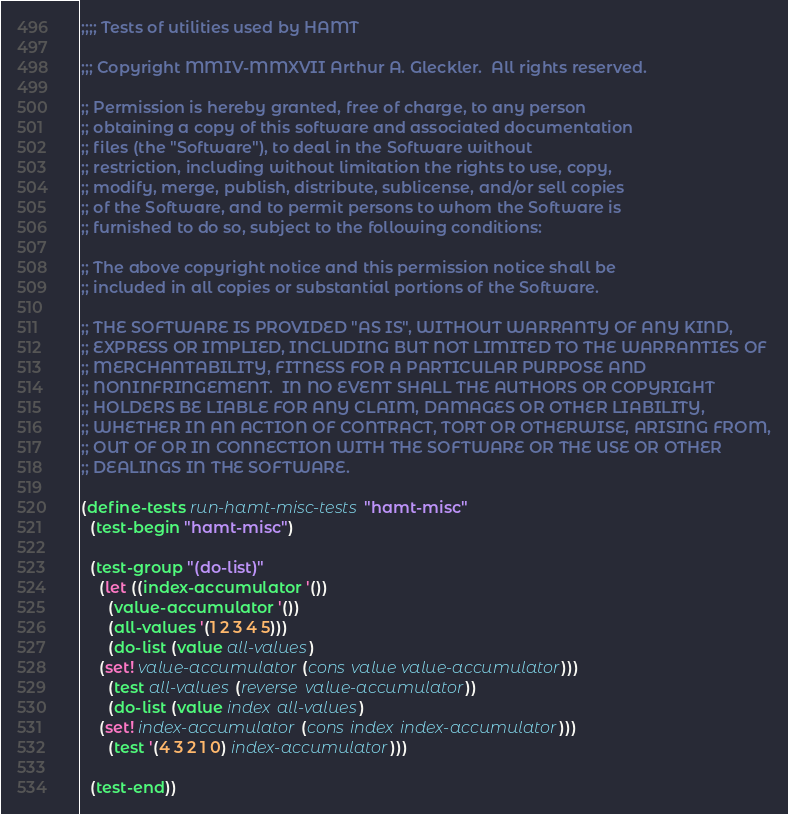Convert code to text. <code><loc_0><loc_0><loc_500><loc_500><_Scheme_>;;;; Tests of utilities used by HAMT

;;; Copyright MMIV-MMXVII Arthur A. Gleckler.  All rights reserved.

;; Permission is hereby granted, free of charge, to any person
;; obtaining a copy of this software and associated documentation
;; files (the "Software"), to deal in the Software without
;; restriction, including without limitation the rights to use, copy,
;; modify, merge, publish, distribute, sublicense, and/or sell copies
;; of the Software, and to permit persons to whom the Software is
;; furnished to do so, subject to the following conditions:

;; The above copyright notice and this permission notice shall be
;; included in all copies or substantial portions of the Software.

;; THE SOFTWARE IS PROVIDED "AS IS", WITHOUT WARRANTY OF ANY KIND,
;; EXPRESS OR IMPLIED, INCLUDING BUT NOT LIMITED TO THE WARRANTIES OF
;; MERCHANTABILITY, FITNESS FOR A PARTICULAR PURPOSE AND
;; NONINFRINGEMENT.  IN NO EVENT SHALL THE AUTHORS OR COPYRIGHT
;; HOLDERS BE LIABLE FOR ANY CLAIM, DAMAGES OR OTHER LIABILITY,
;; WHETHER IN AN ACTION OF CONTRACT, TORT OR OTHERWISE, ARISING FROM,
;; OUT OF OR IN CONNECTION WITH THE SOFTWARE OR THE USE OR OTHER
;; DEALINGS IN THE SOFTWARE.

(define-tests run-hamt-misc-tests "hamt-misc"
  (test-begin "hamt-misc")

  (test-group "(do-list)"
    (let ((index-accumulator '())
	  (value-accumulator '())
	  (all-values '(1 2 3 4 5)))
      (do-list (value all-values)
	(set! value-accumulator (cons value value-accumulator)))
      (test all-values (reverse value-accumulator))
      (do-list (value index all-values)
	(set! index-accumulator (cons index index-accumulator)))
      (test '(4 3 2 1 0) index-accumulator)))

  (test-end))
</code> 